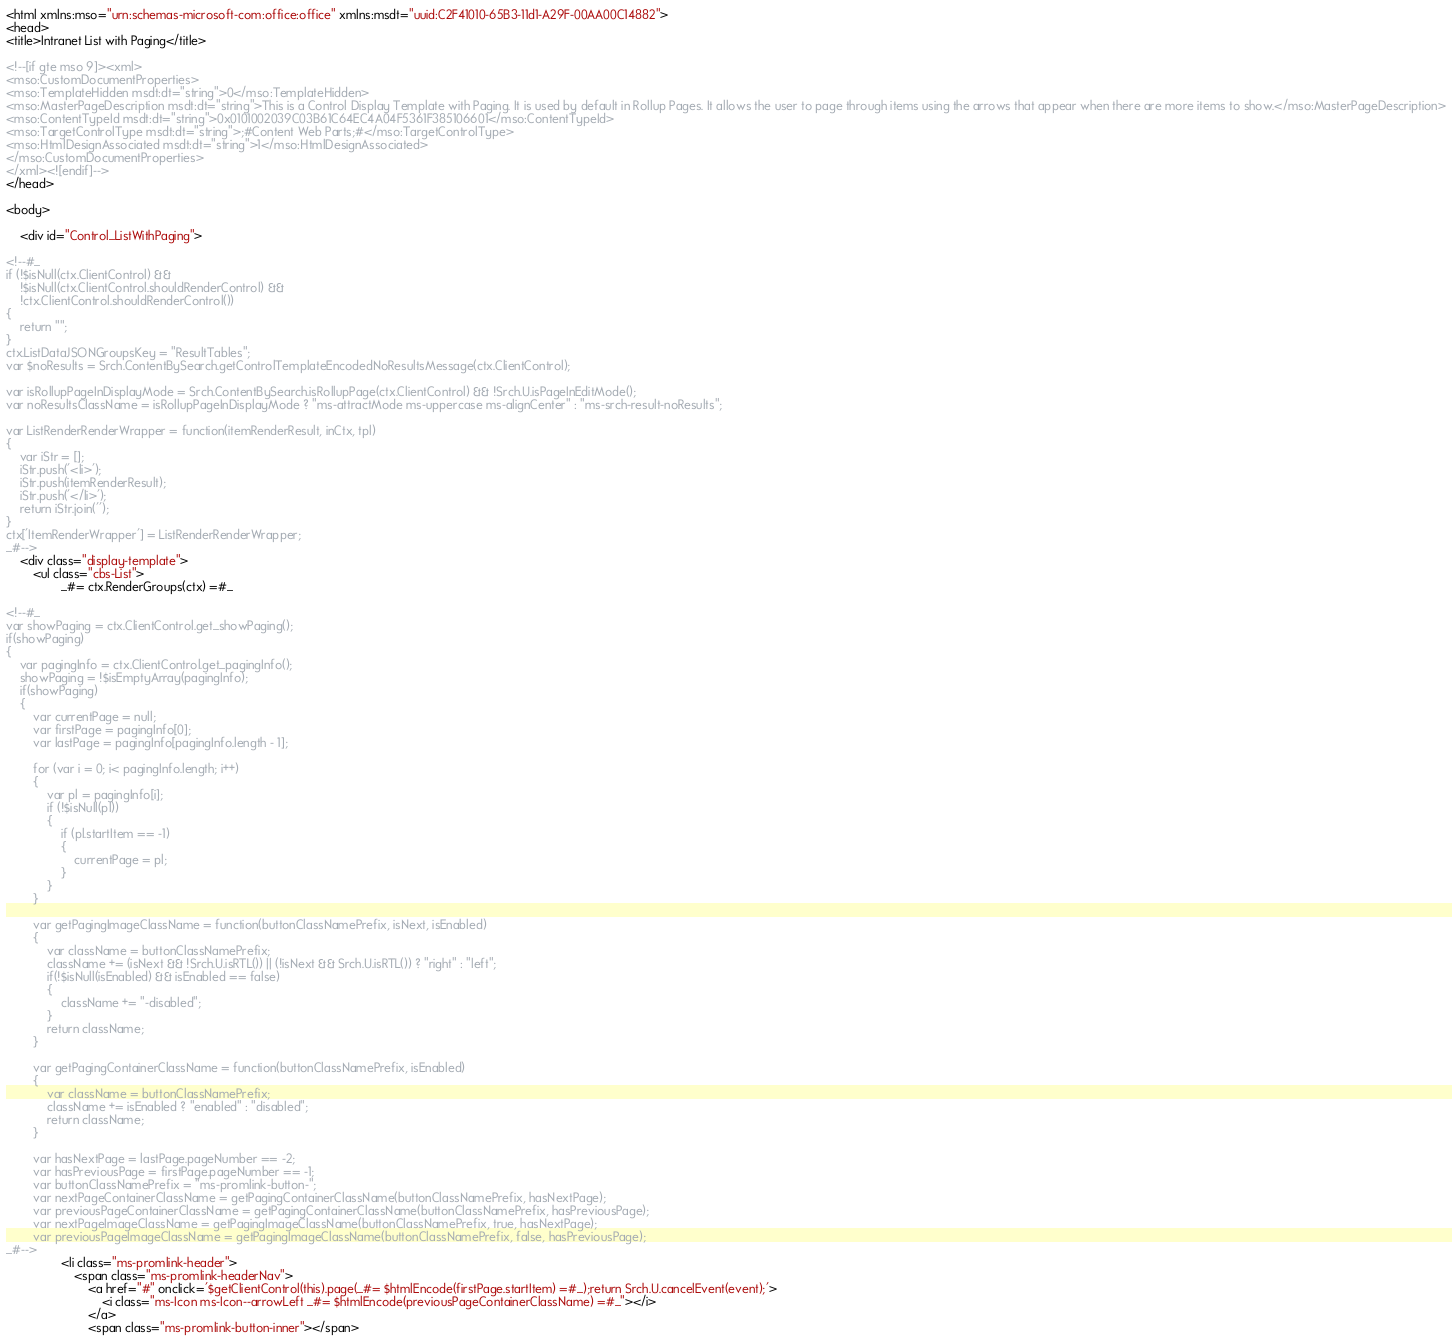<code> <loc_0><loc_0><loc_500><loc_500><_HTML_><html xmlns:mso="urn:schemas-microsoft-com:office:office" xmlns:msdt="uuid:C2F41010-65B3-11d1-A29F-00AA00C14882"> 
<head>
<title>Intranet List with Paging</title>

<!--[if gte mso 9]><xml>
<mso:CustomDocumentProperties>
<mso:TemplateHidden msdt:dt="string">0</mso:TemplateHidden>
<mso:MasterPageDescription msdt:dt="string">This is a Control Display Template with Paging. It is used by default in Rollup Pages. It allows the user to page through items using the arrows that appear when there are more items to show.</mso:MasterPageDescription>
<mso:ContentTypeId msdt:dt="string">0x0101002039C03B61C64EC4A04F5361F385106601</mso:ContentTypeId>
<mso:TargetControlType msdt:dt="string">;#Content Web Parts;#</mso:TargetControlType>
<mso:HtmlDesignAssociated msdt:dt="string">1</mso:HtmlDesignAssociated>
</mso:CustomDocumentProperties>
</xml><![endif]-->
</head>

<body>

    <div id="Control_ListWithPaging">

<!--#_ 
if (!$isNull(ctx.ClientControl) &&
    !$isNull(ctx.ClientControl.shouldRenderControl) &&
    !ctx.ClientControl.shouldRenderControl())
{
    return "";
}
ctx.ListDataJSONGroupsKey = "ResultTables";
var $noResults = Srch.ContentBySearch.getControlTemplateEncodedNoResultsMessage(ctx.ClientControl);

var isRollupPageInDisplayMode = Srch.ContentBySearch.isRollupPage(ctx.ClientControl) && !Srch.U.isPageInEditMode();
var noResultsClassName = isRollupPageInDisplayMode ? "ms-attractMode ms-uppercase ms-alignCenter" : "ms-srch-result-noResults";

var ListRenderRenderWrapper = function(itemRenderResult, inCtx, tpl)
{
    var iStr = [];
    iStr.push('<li>');
    iStr.push(itemRenderResult);
    iStr.push('</li>');
    return iStr.join('');
}
ctx['ItemRenderWrapper'] = ListRenderRenderWrapper;
_#-->
    <div class="display-template">
        <ul class="cbs-List">
                _#= ctx.RenderGroups(ctx) =#_

<!--#_
var showPaging = ctx.ClientControl.get_showPaging();
if(showPaging)
{
    var pagingInfo = ctx.ClientControl.get_pagingInfo();
    showPaging = !$isEmptyArray(pagingInfo);
    if(showPaging)
    {
        var currentPage = null;
        var firstPage = pagingInfo[0];
        var lastPage = pagingInfo[pagingInfo.length - 1];

        for (var i = 0; i< pagingInfo.length; i++)
        {
            var pl = pagingInfo[i];
            if (!$isNull(pl))
            {
                if (pl.startItem == -1)
                {
                    currentPage = pl;
                }
            }
        }

        var getPagingImageClassName = function(buttonClassNamePrefix, isNext, isEnabled)
        {
            var className = buttonClassNamePrefix;
            className += (isNext && !Srch.U.isRTL()) || (!isNext && Srch.U.isRTL()) ? "right" : "left";
            if(!$isNull(isEnabled) && isEnabled == false)
            {
                className += "-disabled";
            }
            return className;
        }

        var getPagingContainerClassName = function(buttonClassNamePrefix, isEnabled)
        {
            var className = buttonClassNamePrefix;
            className += isEnabled ? "enabled" : "disabled";
            return className;
        }

        var hasNextPage = lastPage.pageNumber == -2;
        var hasPreviousPage = firstPage.pageNumber == -1;
        var buttonClassNamePrefix = "ms-promlink-button-";
        var nextPageContainerClassName = getPagingContainerClassName(buttonClassNamePrefix, hasNextPage);
        var previousPageContainerClassName = getPagingContainerClassName(buttonClassNamePrefix, hasPreviousPage);
        var nextPageImageClassName = getPagingImageClassName(buttonClassNamePrefix, true, hasNextPage);
        var previousPageImageClassName = getPagingImageClassName(buttonClassNamePrefix, false, hasPreviousPage);
_#-->
                <li class="ms-promlink-header">
                    <span class="ms-promlink-headerNav">
                        <a href="#" onclick='$getClientControl(this).page(_#= $htmlEncode(firstPage.startItem) =#_);return Srch.U.cancelEvent(event);'>
                        	<i class="ms-Icon ms-Icon--arrowLeft _#= $htmlEncode(previousPageContainerClassName) =#_"></i>
                        </a>
                        <span class="ms-promlink-button-inner"></span></code> 